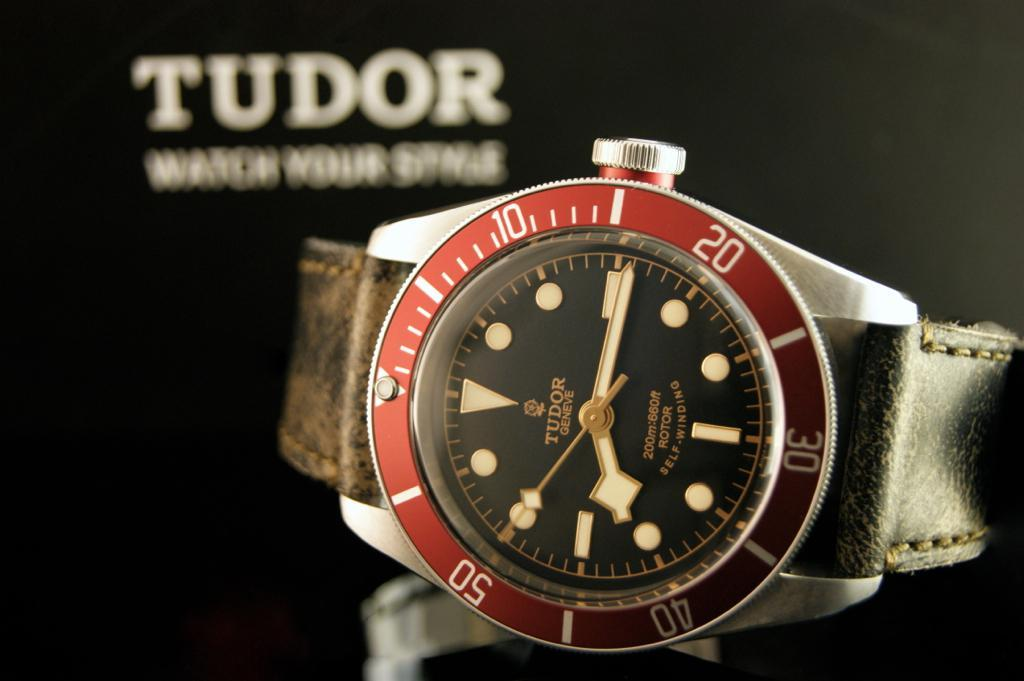Provide a one-sentence caption for the provided image. Face of a watch which has the word TUDOR on it. 